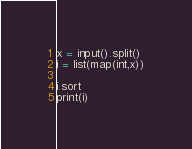Convert code to text. <code><loc_0><loc_0><loc_500><loc_500><_Python_>x = input().split()
i = list(map(int,x))

i.sort
print(i)</code> 